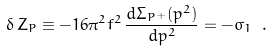Convert formula to latex. <formula><loc_0><loc_0><loc_500><loc_500>\delta \, Z _ { P } \equiv - 1 6 \pi ^ { 2 } f ^ { 2 } \, \frac { d \Sigma _ { P ^ { + } } ( p ^ { 2 } ) } { d p ^ { 2 } } = - \sigma _ { 1 } \ .</formula> 